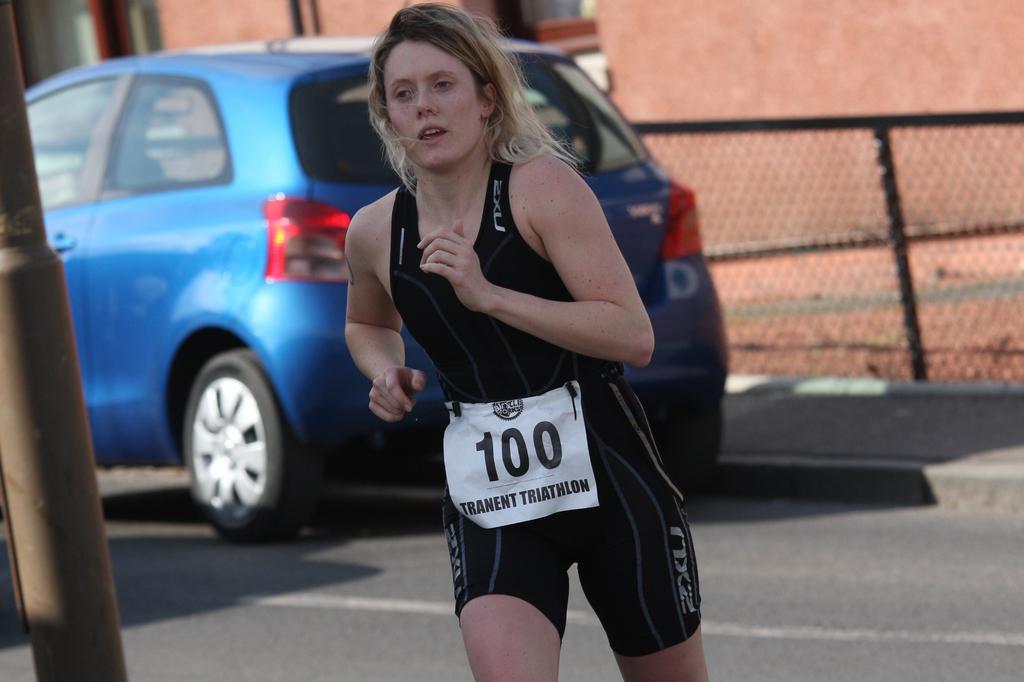Please provide a concise description of this image. In this image we can see a lady. In the background of the image there is a car, fence, building, road and other objects. On the left side of the image it looks like a pole. 